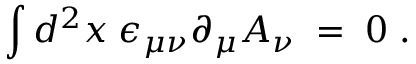<formula> <loc_0><loc_0><loc_500><loc_500>\int d ^ { 2 } x \, \epsilon _ { \mu \nu } \partial _ { \mu } A _ { \nu } \, = \, 0 \, .</formula> 